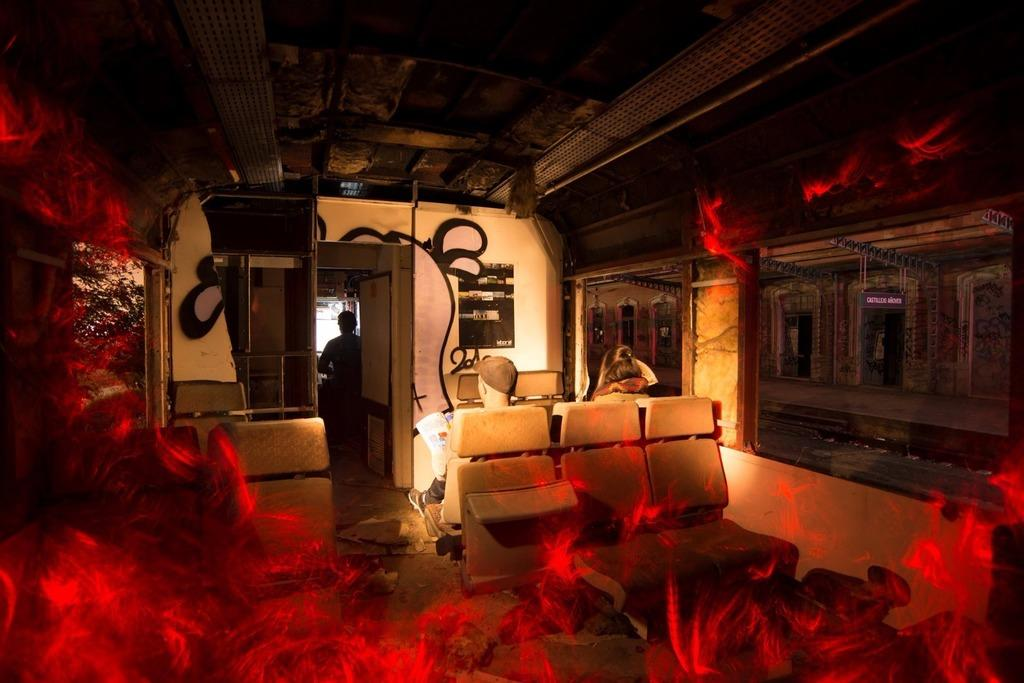How many people are visible in the image? There are two persons sitting on seats and one person standing in the image, making a total of three people. What are the seated persons doing? The seated persons are likely resting or waiting, as they are sitting on seats. What can be seen through the windows in the image? The specific view through the windows is not mentioned, but we know that there are windows present. What is the platform used for in the image? The purpose of the platform is not specified, but it is a raised surface that the seated persons are on. What types of toys are the wrens playing with on the platform in the image? There are no wrens or toys present in the image; it features two seated persons and one standing person on a platform. 